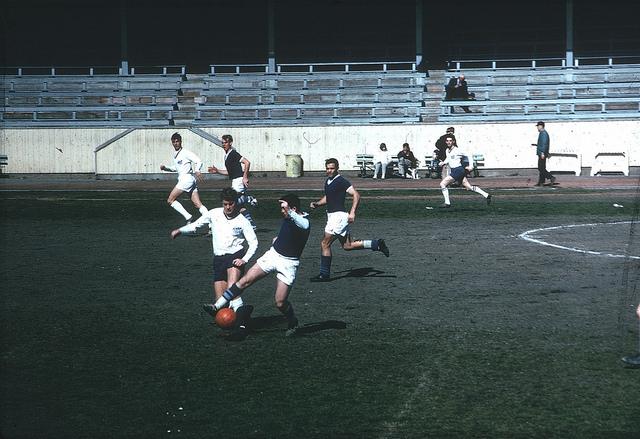Is there a ball pictured?
Be succinct. Yes. What sport are they playing?
Write a very short answer. Soccer. What popular sport is this?
Concise answer only. Soccer. 